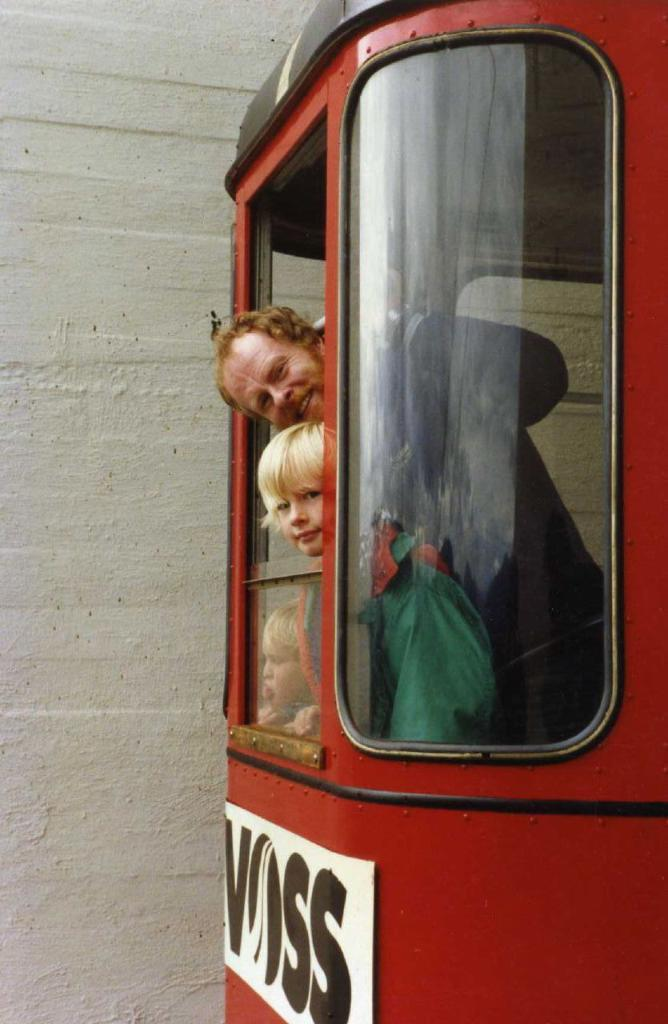How many people are in the vehicle in the image? There are three persons in the vehicle. What is attached to the vehicle that can be seen in the image? There is a board with text attached to the vehicle. What can be seen in the background of the image? There is a wall in the background of the image. How many dimes are visible on the board attached to the vehicle? There are no dimes visible on the board attached to the vehicle; it has text on it. What type of dolls can be seen playing near the vehicle? There are no dolls present in the image. 